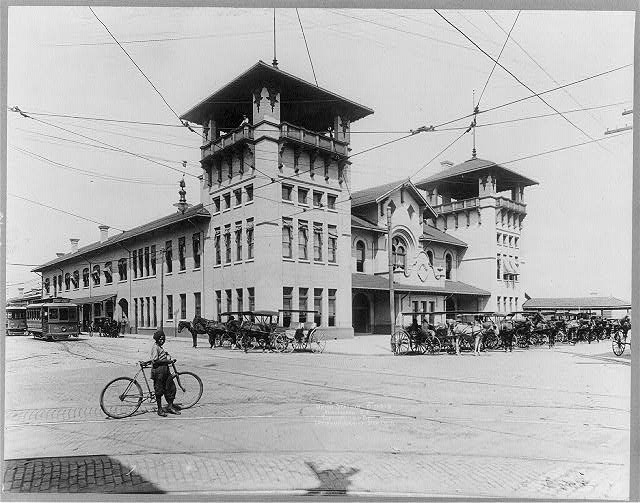Describe the objects in this image and their specific colors. I can see bicycle in darkgray, gray, black, and lightgray tones, bus in darkgray, black, gray, and lightgray tones, people in darkgray, black, gray, and lightgray tones, horse in darkgray, lightgray, gray, and black tones, and bus in darkgray, black, gray, and lightgray tones in this image. 